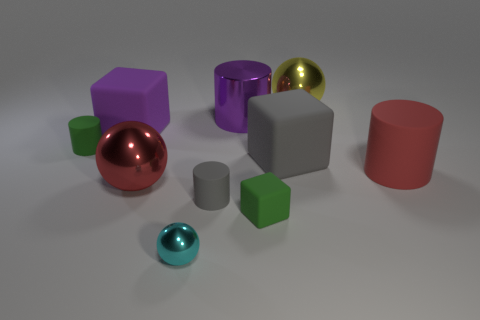There is a cyan object that is the same size as the green rubber cube; what is it made of?
Offer a very short reply. Metal. How many other objects are the same material as the tiny ball?
Give a very brief answer. 3. There is a big object that is in front of the cylinder that is on the right side of the green cube; what shape is it?
Offer a terse response. Sphere. How many things are things or large yellow shiny things that are behind the large rubber cylinder?
Provide a succinct answer. 10. What number of other objects are the same color as the big matte cylinder?
Offer a terse response. 1. What number of gray things are either big rubber cylinders or big rubber balls?
Give a very brief answer. 0. There is a tiny object that is behind the big shiny ball on the left side of the yellow ball; is there a green object that is in front of it?
Provide a succinct answer. Yes. There is a big matte cube that is right of the red object on the left side of the tiny ball; what color is it?
Ensure brevity in your answer.  Gray. How many large objects are either gray blocks or green matte blocks?
Your answer should be very brief. 1. There is a metal object that is behind the big matte cylinder and in front of the yellow object; what color is it?
Provide a short and direct response. Purple. 